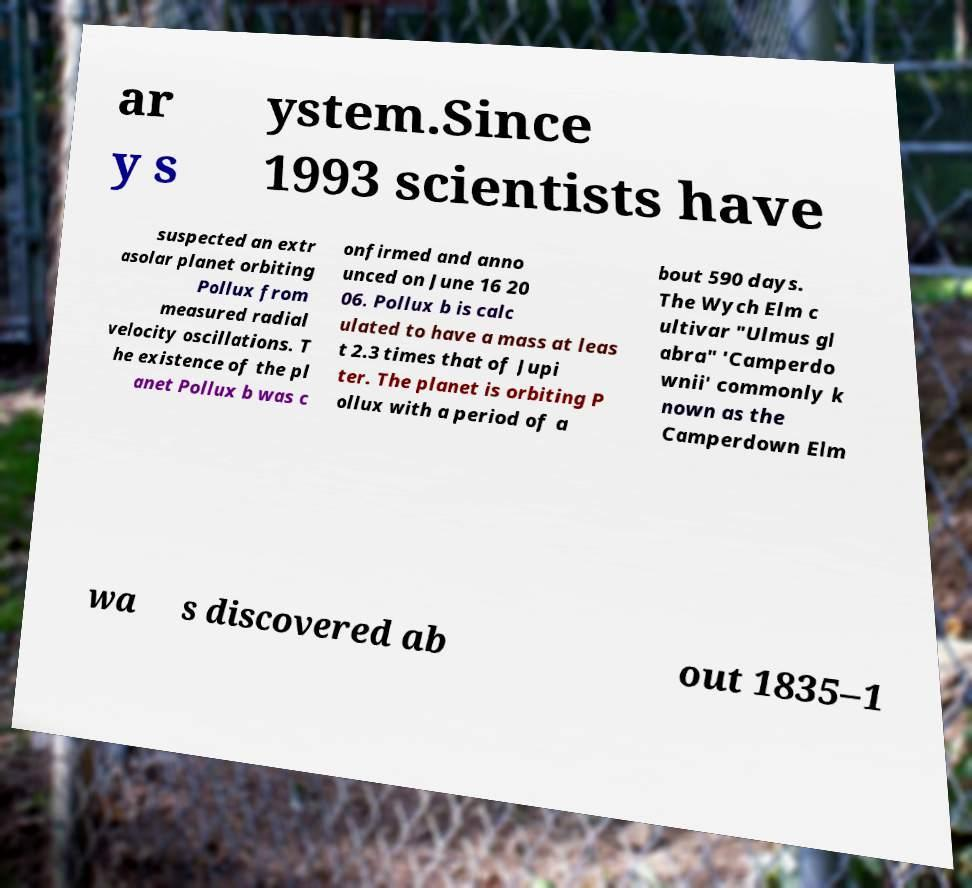Can you read and provide the text displayed in the image?This photo seems to have some interesting text. Can you extract and type it out for me? ar y s ystem.Since 1993 scientists have suspected an extr asolar planet orbiting Pollux from measured radial velocity oscillations. T he existence of the pl anet Pollux b was c onfirmed and anno unced on June 16 20 06. Pollux b is calc ulated to have a mass at leas t 2.3 times that of Jupi ter. The planet is orbiting P ollux with a period of a bout 590 days. The Wych Elm c ultivar "Ulmus gl abra" 'Camperdo wnii' commonly k nown as the Camperdown Elm wa s discovered ab out 1835–1 